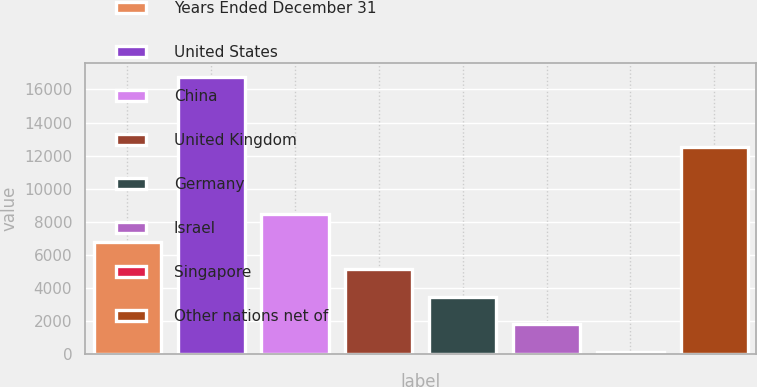<chart> <loc_0><loc_0><loc_500><loc_500><bar_chart><fcel>Years Ended December 31<fcel>United States<fcel>China<fcel>United Kingdom<fcel>Germany<fcel>Israel<fcel>Singapore<fcel>Other nations net of<nl><fcel>6793.2<fcel>16749<fcel>8452.5<fcel>5133.9<fcel>3474.6<fcel>1815.3<fcel>156<fcel>12549<nl></chart> 